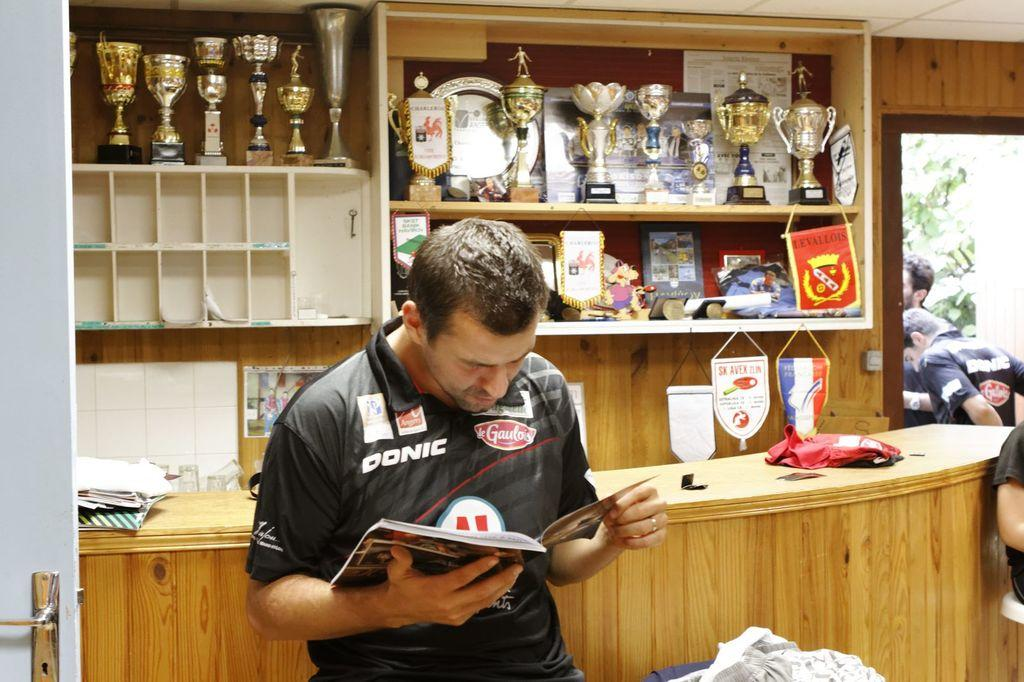<image>
Give a short and clear explanation of the subsequent image. A man reading a book in a Donic jersey with trophies behind him. 